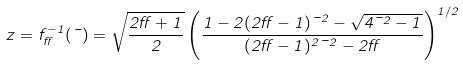Convert formula to latex. <formula><loc_0><loc_0><loc_500><loc_500>\ z = f ^ { - 1 } _ { \alpha } ( \mu ) = \sqrt { \frac { 2 \alpha + 1 } { 2 } } \left ( \frac { 1 - 2 ( 2 \alpha - 1 ) \mu ^ { 2 } - \sqrt { 4 \mu ^ { 2 } - 1 } } { ( 2 \alpha - 1 ) ^ { 2 } \mu ^ { 2 } - 2 \alpha } \right ) ^ { 1 / 2 }</formula> 